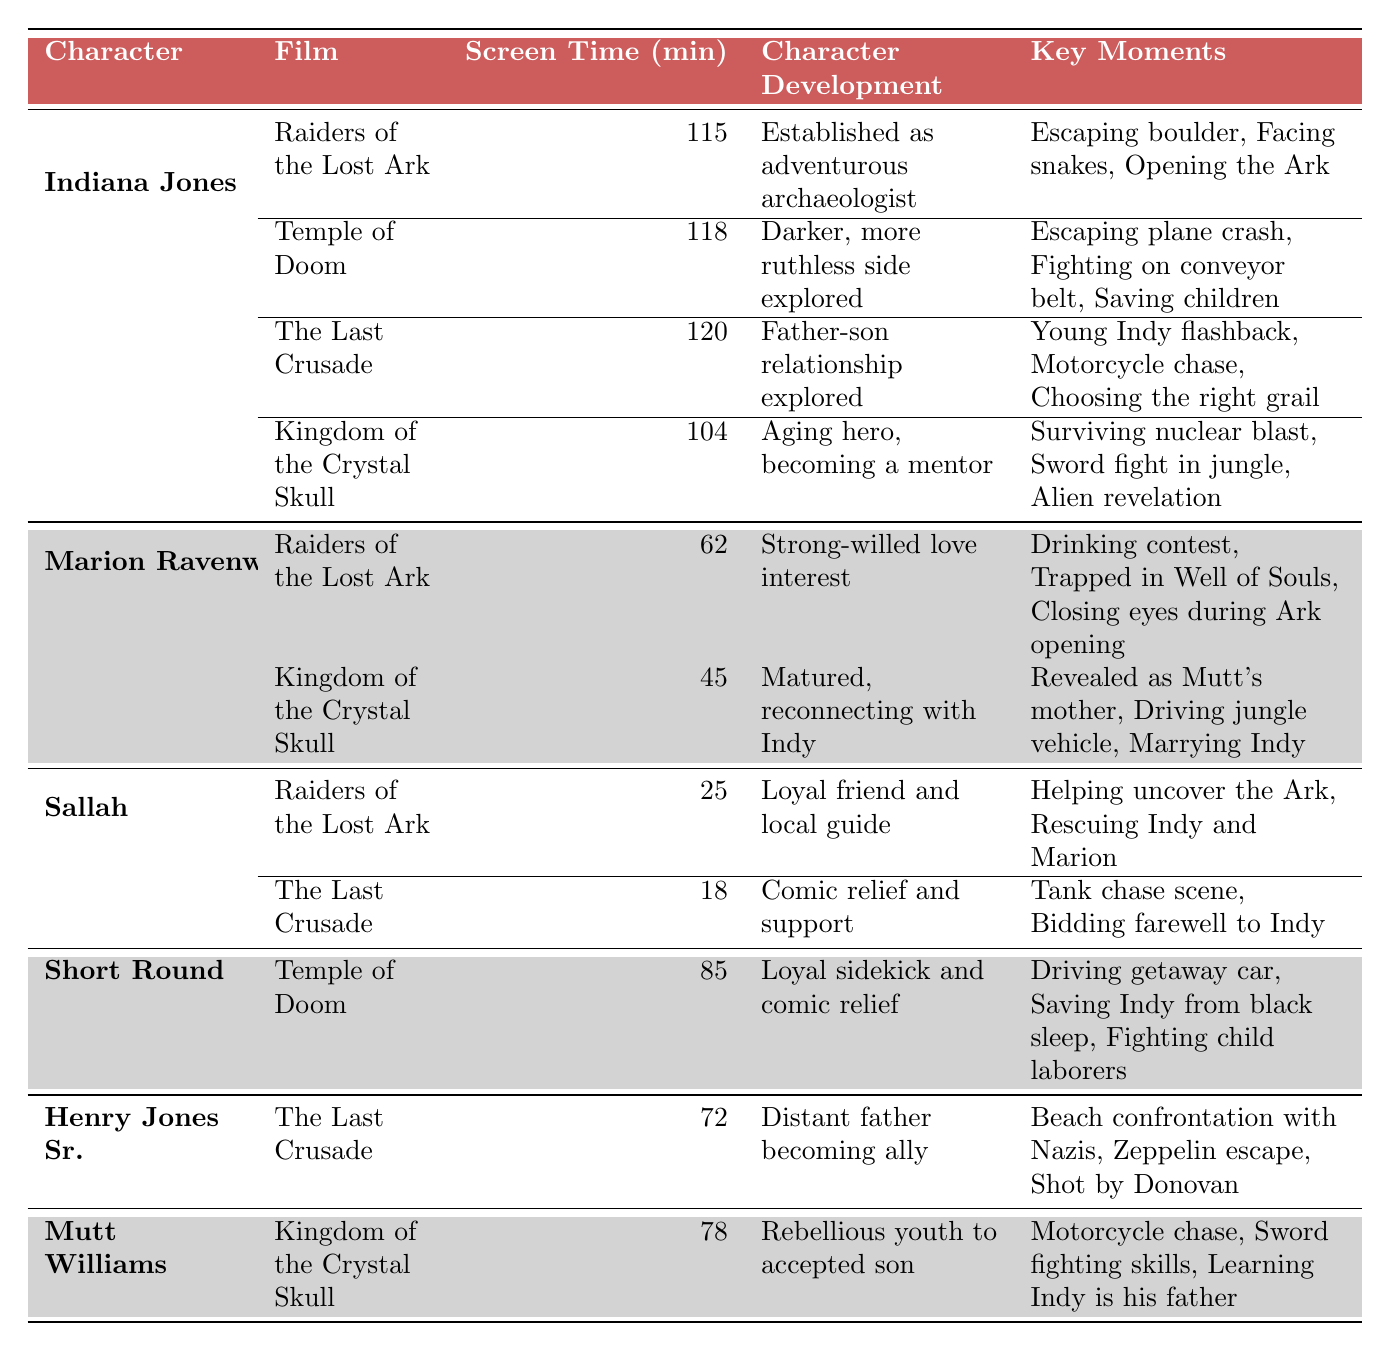What is the total screen time for Indiana Jones in all films? Indiana Jones appears in four films: Raiders of the Lost Ark (115 min), Temple of Doom (118 min), The Last Crusade (120 min), and Kingdom of the Crystal Skull (104 min). Adding these values: 115 + 118 + 120 + 104 = 457 minutes.
Answer: 457 minutes Which character has the most screen time and how much is it? Indiana Jones has the highest screen time with 115 minutes in Raiders of the Lost Ark, 118 minutes in Temple of Doom, 120 minutes in The Last Crusade, and 104 minutes in Kingdom of the Crystal Skull. The screen time in The Last Crusade is the highest among all characters, which is 120 minutes.
Answer: Indiana Jones with 120 minutes How many characters have their screen time analyzed in only one film? Short Round, Henry Jones Sr., and Mutt Williams each have their screen time analyzed in only one film (Temple of Doom, The Last Crusade, and Kingdom of the Crystal Skull respectively), making a total of three characters.
Answer: 3 What is the average screen time for Marion Ravenwood across her films? Marion Ravenwood has two screen times: 62 minutes in Raiders of the Lost Ark and 45 minutes in Kingdom of the Crystal Skull. The average is calculated as (62 + 45) / 2 = 53.5 minutes.
Answer: 53.5 minutes Did Sallah appear in more than one film, and if so, what is his total screen time? Sallah appears in two films: Raiders of the Lost Ark (25 min) and The Last Crusade (18 min). His total screen time is 25 + 18 = 43 minutes.
Answer: Yes, 43 minutes How has Indiana Jones' character development evolved throughout the films? Indiana Jones' character development starts with him as an adventurous archaeologist, evolves to show a darker side, then reveals a father-son relationship, and finally portrays him as an aging hero transitioning into a mentor role.
Answer: From adventurous archaeologist to an aging mentor In which film did Marion Ravenwood display the least screen time and what was it? Marion Ravenwood had the least screen time in Kingdom of the Crystal Skull, where she appeared for 45 minutes.
Answer: Kingdom of the Crystal Skull, 45 minutes What percentage of screen time does Short Round contribute compared to Indiana Jones in Temple of Doom? Short Round has 85 minutes of screen time, while Indiana Jones has 118 minutes in Temple of Doom. The percentage is calculated as (85 / 118) * 100 = 72.03%.
Answer: 72.03% Which character has the least overall screen time across all films in the table? The character with the least overall screen time is Sallah, with 25 minutes in Raiders of the Lost Ark and 18 minutes in The Last Crusade, totaling 43 minutes.
Answer: Sallah, 43 minutes What was the character development of Mutt Williams in Kingdom of the Crystal Skull? Mutt Williams developed from a rebellious youth to being recognized as Indy's accepted son throughout the film Kingdom of the Crystal Skull.
Answer: Rebellious youth to accepted son 